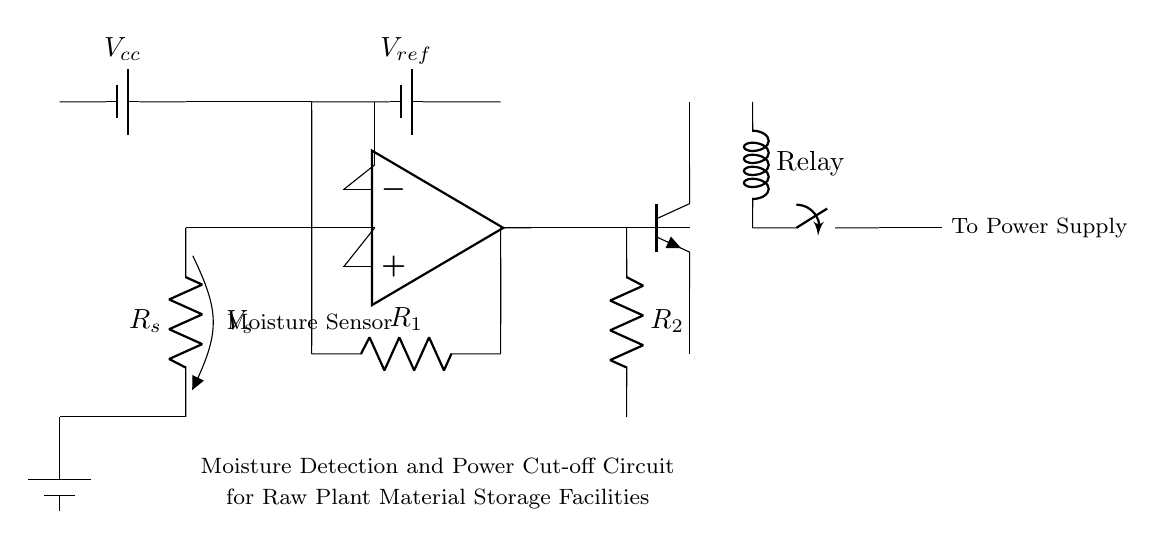What type of sensor is used in this circuit? The circuit uses a moisture sensor, indicated by the labeled component in the diagram.
Answer: Moisture Sensor What is the reference voltage labeled as in the circuit? The reference voltage is labeled as V ref which is connected to the comparator.
Answer: V ref Which component is responsible for detecting moisture levels? The moisture sensor is responsible for detecting moisture levels, as named in the circuit.
Answer: Moisture Sensor What is the purpose of the relay in this circuit? The relay is used to cut off power in case of moisture detection, preventing potential damage to materials stored.
Answer: Power cut-off How does the comparator function in this moisture detection circuit? The comparator compares the voltage from the moisture sensor against the reference voltage and activates the relay if the moisture level is beyond a certain threshold.
Answer: Compares voltages What happens when the moisture level exceeds the reference voltage? When the moisture level exceeds the reference voltage, the comparator triggers the transistor which actuates the relay to cut off power.
Answer: Power is cut off What is the role of the NPN transistor in this circuit? The NPN transistor serves as a relay driver, switching the relay on or off based on the signals from the comparator.
Answer: Relay driver 